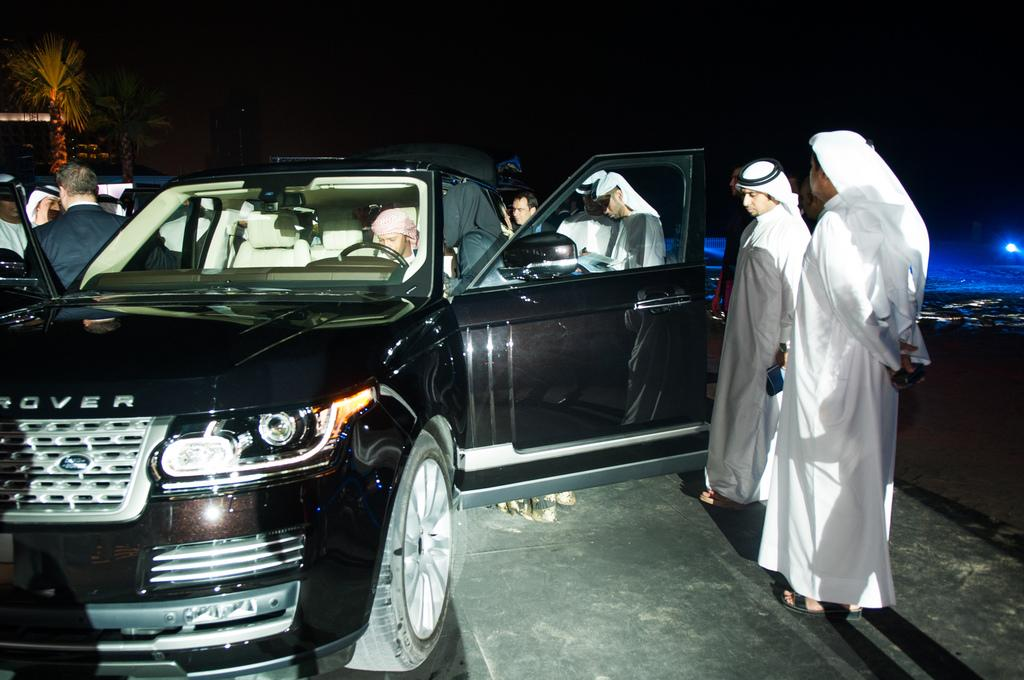What is the color of the car in the image? The car in the image is black. Who is inside the car? There is a person inside the car. What can be observed about the people around the car? The people around the car are wearing white color dress. Can you describe the setting of the image? The image features a black car with a person inside and people wearing white dresses around it. What are the thoughts of the mint in the image? There is no mint present in the image, so it is not possible to determine its thoughts. 